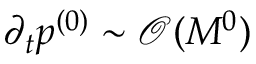Convert formula to latex. <formula><loc_0><loc_0><loc_500><loc_500>\partial _ { t } { p ^ { ( 0 ) } } \sim { \mathcal { O } ( M ^ { 0 } ) }</formula> 